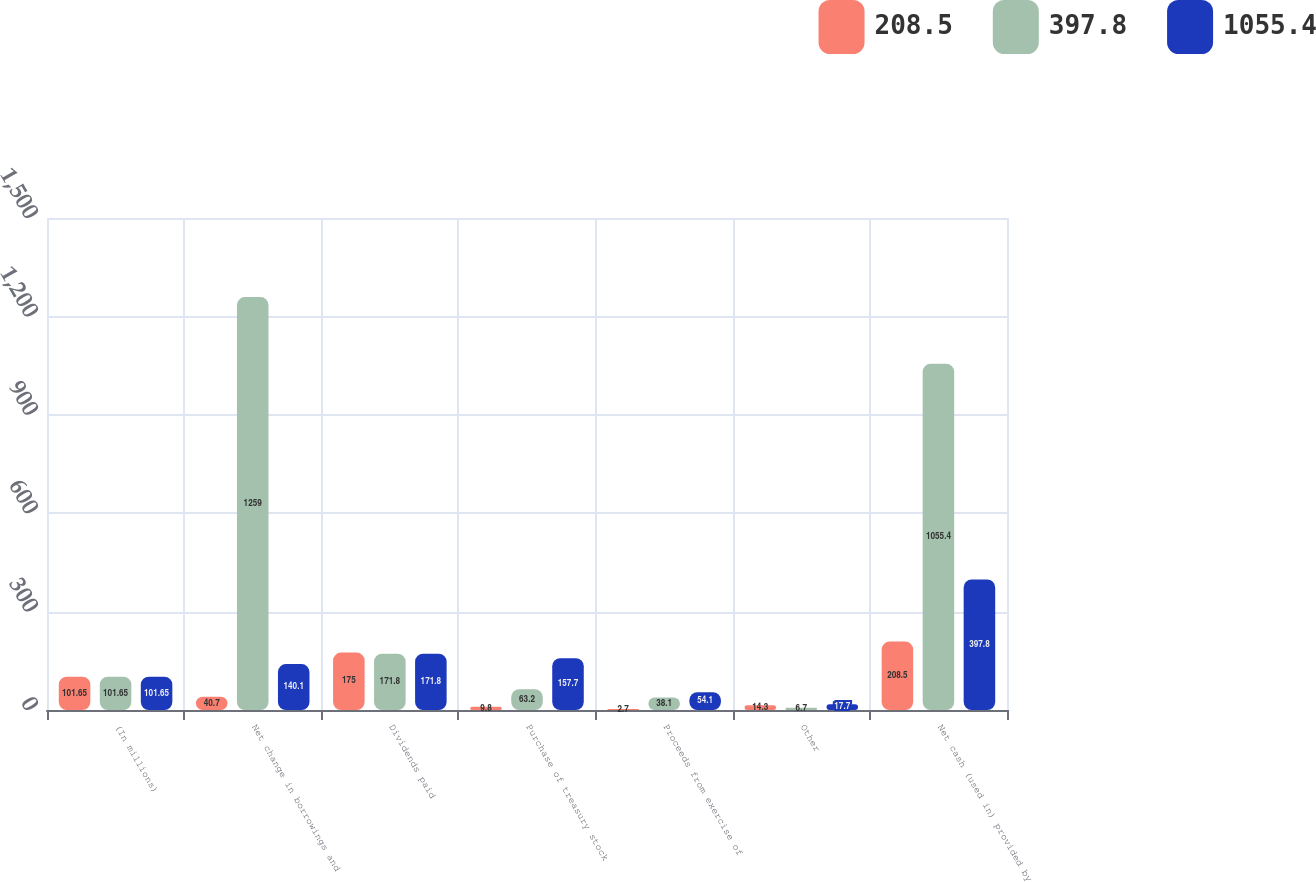<chart> <loc_0><loc_0><loc_500><loc_500><stacked_bar_chart><ecel><fcel>(In millions)<fcel>Net change in borrowings and<fcel>Dividends paid<fcel>Purchase of treasury stock<fcel>Proceeds from exercise of<fcel>Other<fcel>Net cash (used in) provided by<nl><fcel>208.5<fcel>101.65<fcel>40.7<fcel>175<fcel>9.8<fcel>2.7<fcel>14.3<fcel>208.5<nl><fcel>397.8<fcel>101.65<fcel>1259<fcel>171.8<fcel>63.2<fcel>38.1<fcel>6.7<fcel>1055.4<nl><fcel>1055.4<fcel>101.65<fcel>140.1<fcel>171.8<fcel>157.7<fcel>54.1<fcel>17.7<fcel>397.8<nl></chart> 